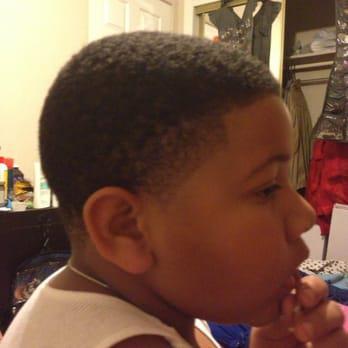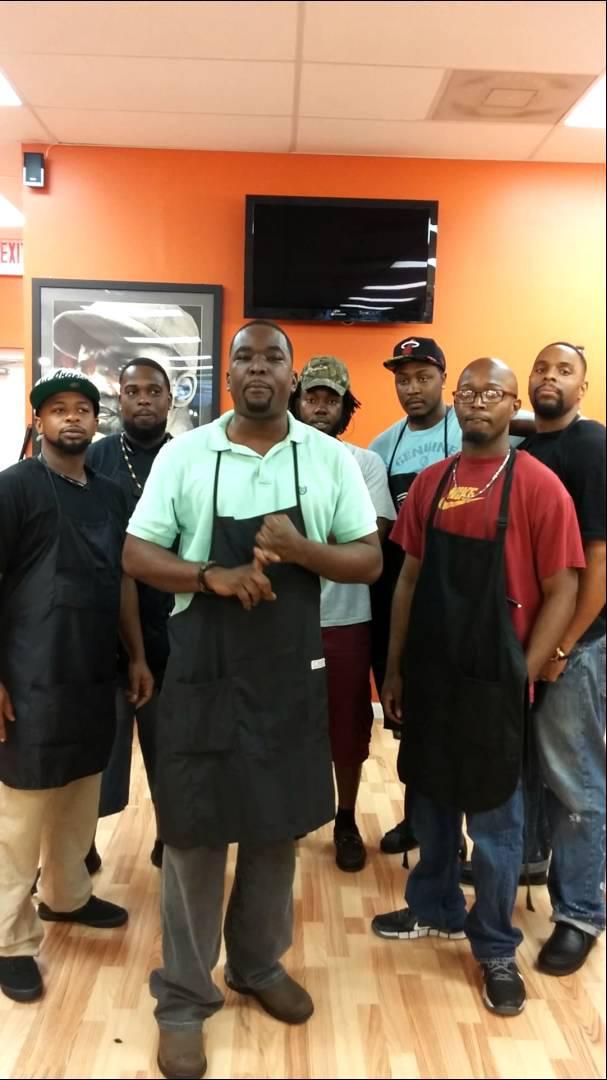The first image is the image on the left, the second image is the image on the right. For the images shown, is this caption "There  Is it least one tall black man with little to no hair on his head wearing an apron in a barbershop." true? Answer yes or no. Yes. The first image is the image on the left, the second image is the image on the right. Analyze the images presented: Is the assertion "You can see there is a TV hanging on the wall in at least one of the images." valid? Answer yes or no. Yes. 